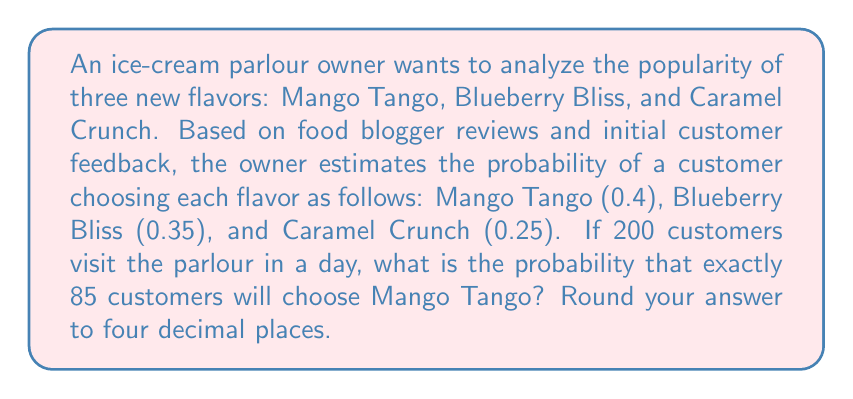Help me with this question. To solve this problem, we'll use the binomial probability distribution, as we're dealing with a fixed number of independent trials (customers) with a constant probability of success (choosing Mango Tango).

Step 1: Identify the parameters
- $n$ = number of trials (customers) = 200
- $p$ = probability of success (choosing Mango Tango) = 0.4
- $k$ = number of successes we're interested in = 85

Step 2: Use the binomial probability formula
The probability of exactly $k$ successes in $n$ trials is given by:

$$ P(X = k) = \binom{n}{k} p^k (1-p)^{n-k} $$

Where $\binom{n}{k}$ is the binomial coefficient, calculated as:

$$ \binom{n}{k} = \frac{n!}{k!(n-k)!} $$

Step 3: Calculate the binomial coefficient
$$ \binom{200}{85} = \frac{200!}{85!(200-85)!} = \frac{200!}{85!115!} $$

Step 4: Plug values into the binomial probability formula
$$ P(X = 85) = \binom{200}{85} (0.4)^{85} (1-0.4)^{200-85} $$
$$ = \binom{200}{85} (0.4)^{85} (0.6)^{115} $$

Step 5: Calculate the result
Using a calculator or computer software to handle the large numbers, we get:

$$ P(X = 85) \approx 0.0541 $$

Rounding to four decimal places, we get 0.0541.
Answer: 0.0541 